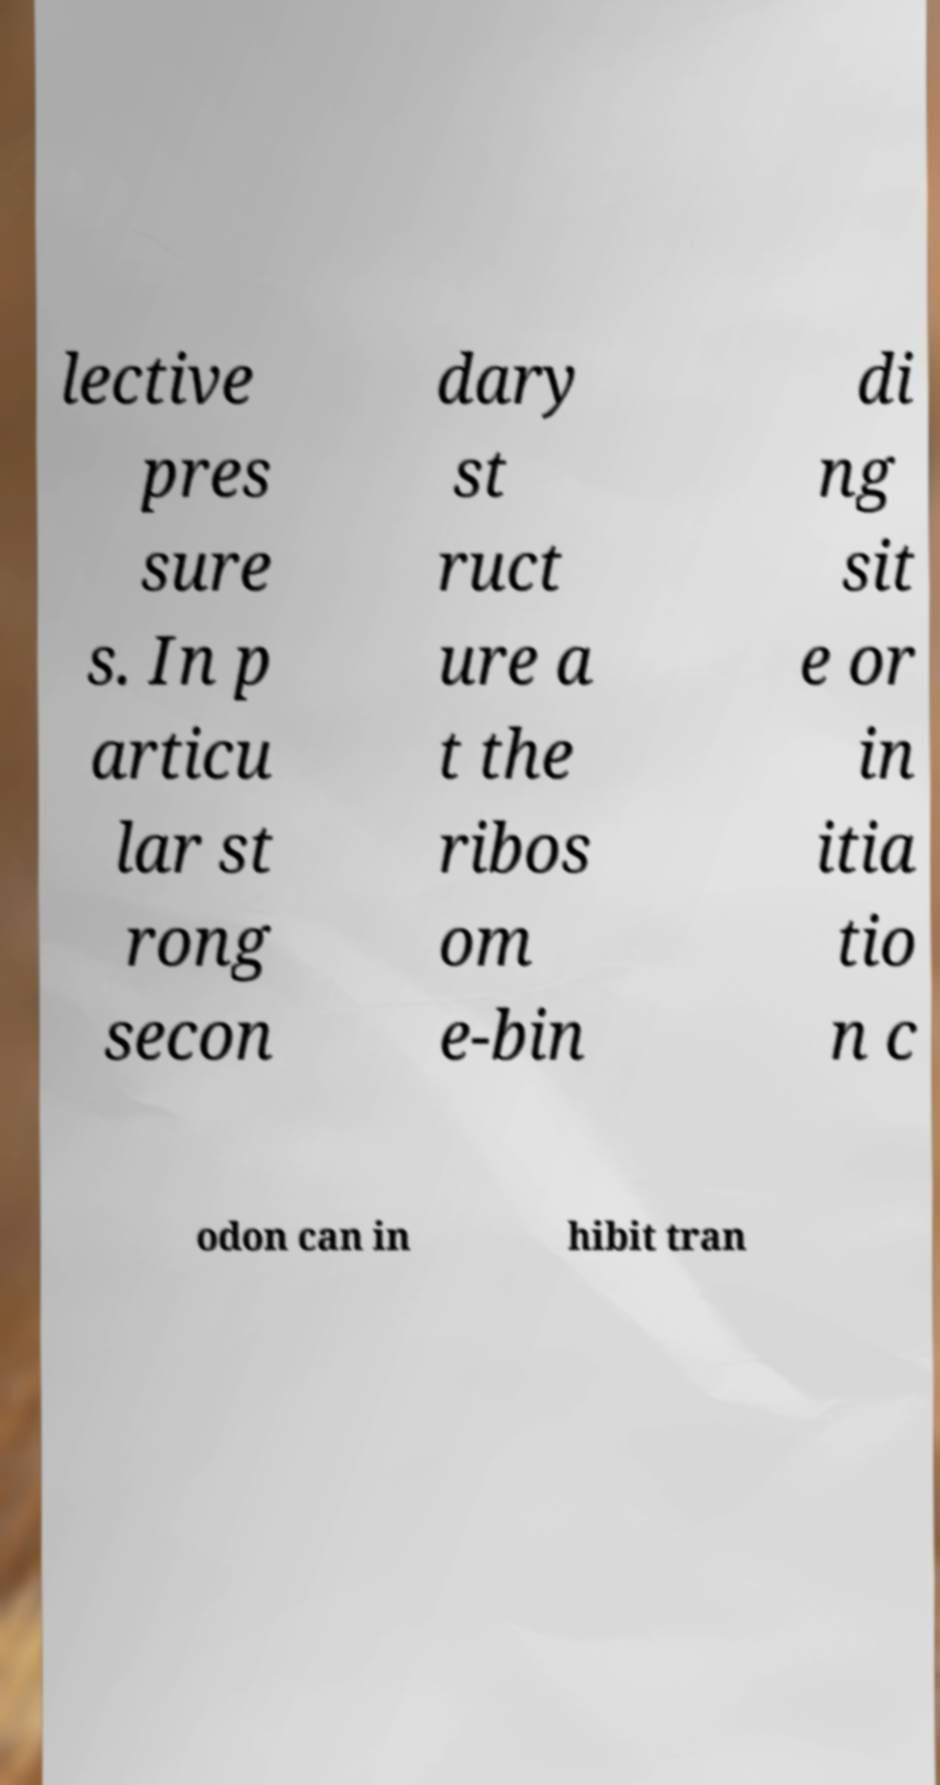Can you accurately transcribe the text from the provided image for me? lective pres sure s. In p articu lar st rong secon dary st ruct ure a t the ribos om e-bin di ng sit e or in itia tio n c odon can in hibit tran 